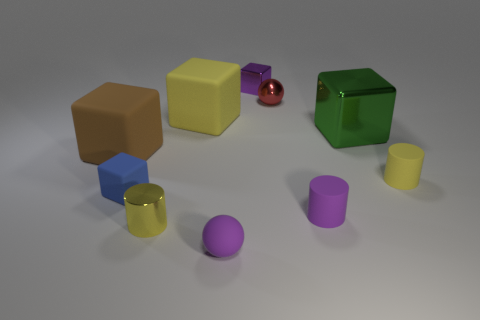Subtract all tiny metal cylinders. How many cylinders are left? 2 Subtract all purple cubes. How many yellow cylinders are left? 2 Subtract all yellow blocks. How many blocks are left? 4 Subtract all gray cylinders. Subtract all purple blocks. How many cylinders are left? 3 Subtract all spheres. How many objects are left? 8 Add 1 small metal cylinders. How many small metal cylinders are left? 2 Add 4 tiny purple rubber objects. How many tiny purple rubber objects exist? 6 Subtract 1 yellow cubes. How many objects are left? 9 Subtract all big red shiny balls. Subtract all big green metal objects. How many objects are left? 9 